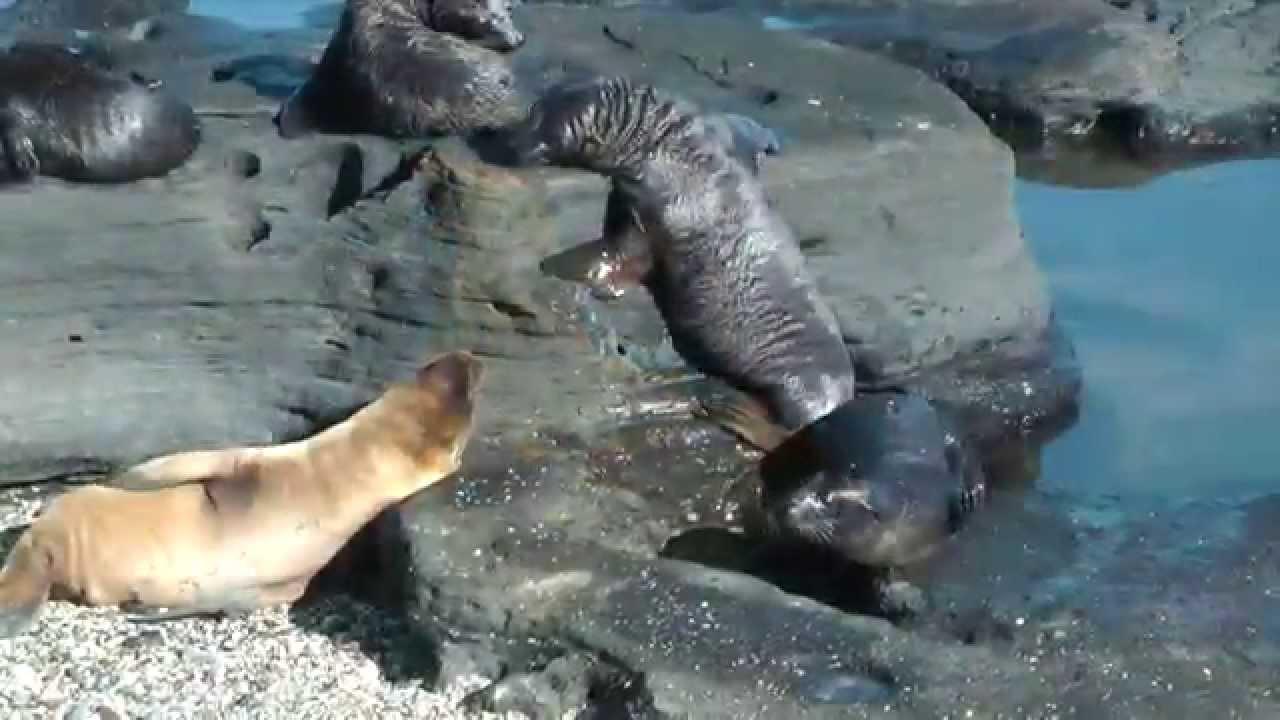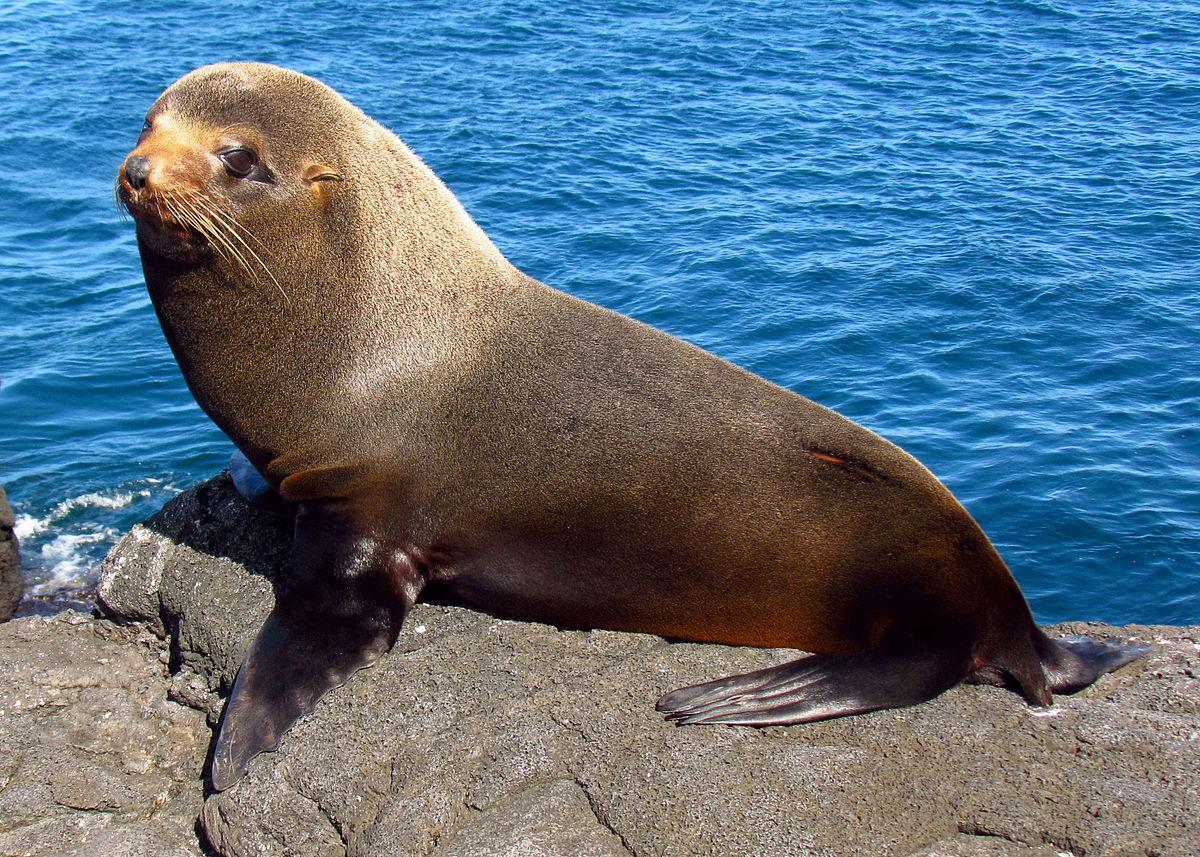The first image is the image on the left, the second image is the image on the right. Analyze the images presented: Is the assertion "The left image contains exactly two seals." valid? Answer yes or no. No. 